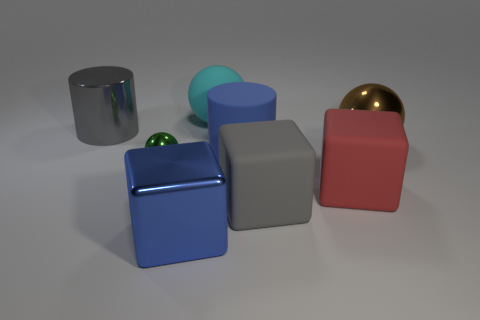Add 1 large red shiny cylinders. How many objects exist? 9 Subtract all cylinders. How many objects are left? 6 Add 1 large objects. How many large objects exist? 8 Subtract 0 gray spheres. How many objects are left? 8 Subtract all tiny metal blocks. Subtract all blue cylinders. How many objects are left? 7 Add 2 gray matte objects. How many gray matte objects are left? 3 